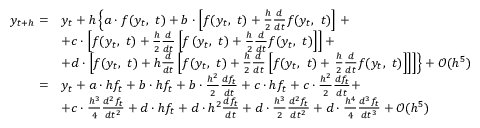<formula> <loc_0><loc_0><loc_500><loc_500>{ \begin{array} { r l } { y _ { t + h } = } & { y _ { t } + h \left \{ a \cdot f ( y _ { t } , \ t ) + b \cdot \left [ f ( y _ { t } , \ t ) + { \frac { h } { 2 } } { \frac { d } { d t } } f ( y _ { t } , \ t ) \right ] + } \\ & { + c \cdot \left [ f ( y _ { t } , \ t ) + { \frac { h } { 2 } } { \frac { d } { d t } } \left [ f \left ( y _ { t } , \ t \right ) + { \frac { h } { 2 } } { \frac { d } { d t } } f ( y _ { t } , \ t ) \right ] \right ] + } \\ & { + d \cdot \left [ f ( y _ { t } , \ t ) + h { \frac { d } { d t } } \left [ f ( y _ { t } , \ t ) + { \frac { h } { 2 } } { \frac { d } { d t } } \left [ f ( y _ { t } , \ t ) + { \frac { h } { 2 } } { \frac { d } { d t } } f ( y _ { t } , \ t ) \right ] \right ] \right ] \right \} + { \mathcal { O } } ( h ^ { 5 } ) } \\ { = } & { y _ { t } + a \cdot h f _ { t } + b \cdot h f _ { t } + b \cdot { \frac { h ^ { 2 } } { 2 } } { \frac { d f _ { t } } { d t } } + c \cdot h f _ { t } + c \cdot { \frac { h ^ { 2 } } { 2 } } { \frac { d f _ { t } } { d t } } + } \\ & { + c \cdot { \frac { h ^ { 3 } } { 4 } } { \frac { d ^ { 2 } f _ { t } } { d t ^ { 2 } } } + d \cdot h f _ { t } + d \cdot h ^ { 2 } { \frac { d f _ { t } } { d t } } + d \cdot { \frac { h ^ { 3 } } { 2 } } { \frac { d ^ { 2 } f _ { t } } { d t ^ { 2 } } } + d \cdot { \frac { h ^ { 4 } } { 4 } } { \frac { d ^ { 3 } f _ { t } } { d t ^ { 3 } } } + { \mathcal { O } } ( h ^ { 5 } ) } \end{array} }</formula> 